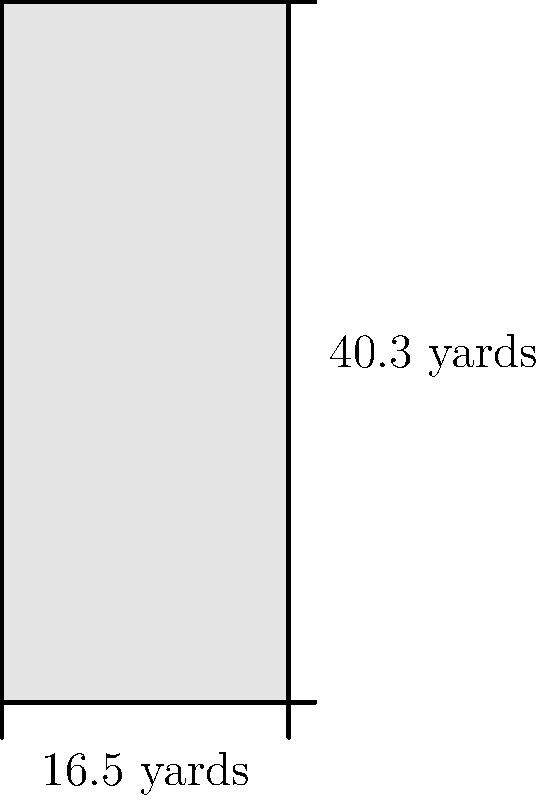As a football commentator and historian, you're analyzing the dimensions of a penalty box. Given that the width of the penalty box is 16.5 yards and the length is 40.3 yards, what is the total area of the penalty box in square yards? To calculate the area of the penalty box, we need to multiply its width by its length. Let's break it down step-by-step:

1. Given dimensions:
   - Width = 16.5 yards
   - Length = 40.3 yards

2. Area formula for a rectangle:
   $$ \text{Area} = \text{Width} \times \text{Length} $$

3. Plugging in the values:
   $$ \text{Area} = 16.5 \text{ yards} \times 40.3 \text{ yards} $$

4. Performing the multiplication:
   $$ \text{Area} = 665.95 \text{ square yards} $$

5. Rounding to two decimal places:
   $$ \text{Area} \approx 665.95 \text{ square yards} $$

Therefore, the total area of the penalty box is approximately 665.95 square yards.
Answer: 665.95 square yards 